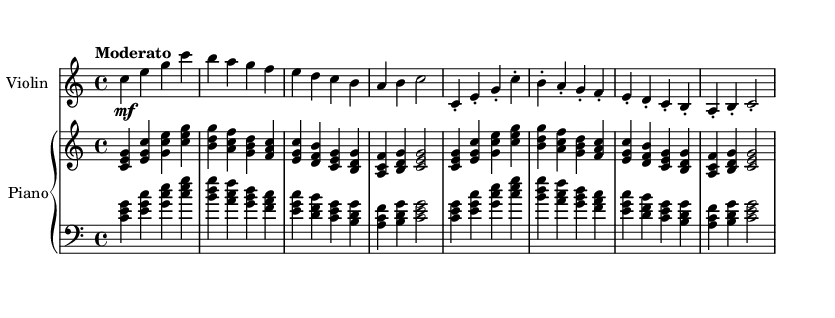What is the key signature of this music? The key signature is indicated at the beginning of the staff. It shows no sharps or flats, which denotes the key of C major.
Answer: C major What is the time signature of this composition? The time signature is found at the beginning of the staff, represented as "4/4". This means there are four beats in a measure and a quarter note gets one beat.
Answer: 4/4 What is the tempo marking for this piece? The tempo is expressed above the staff, marked as "Moderato". This denotes a moderate speed in performance.
Answer: Moderato How many measures are there in the violin part? By counting the individual bars (or measures) in the violin part, it is observed that there are a total of 8 measures.
Answer: 8 What is the last note in the piano part? To find the last note, locate the end of the piano part in the notation. The last note clearly shown is a C note, which is played in the upper staff.
Answer: C Which instrument plays staccato notes? Observing the notation, the staccato marks are present in the violin part, indicating that those notes should be played short and detached.
Answer: Violin How many distinct sections are present in the piano part? By analyzing the piano part, there are distinct patterns and sections that repeat, particularly identifiable in the structure, which shows a total of 3 distinct sections.
Answer: 3 